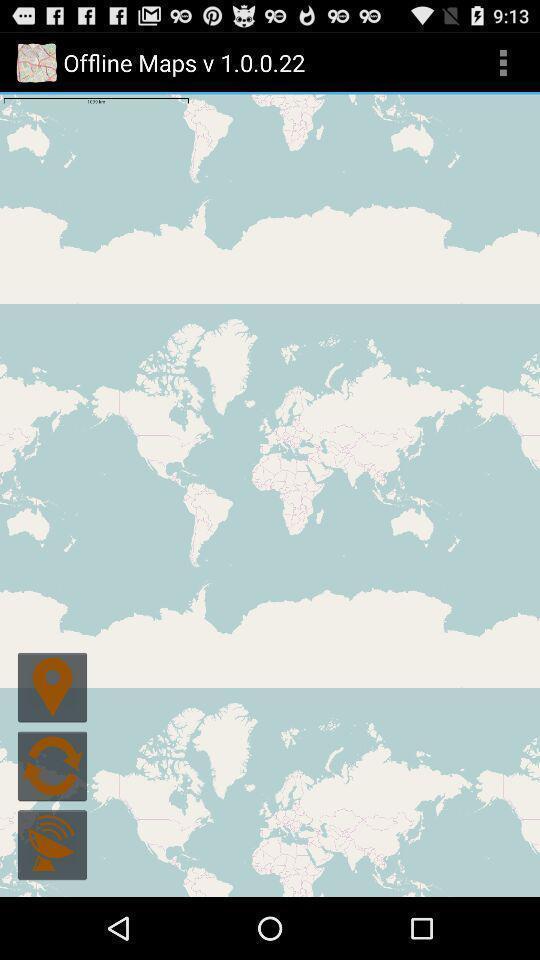Summarize the information in this screenshot. Screen showing various icons like location. 